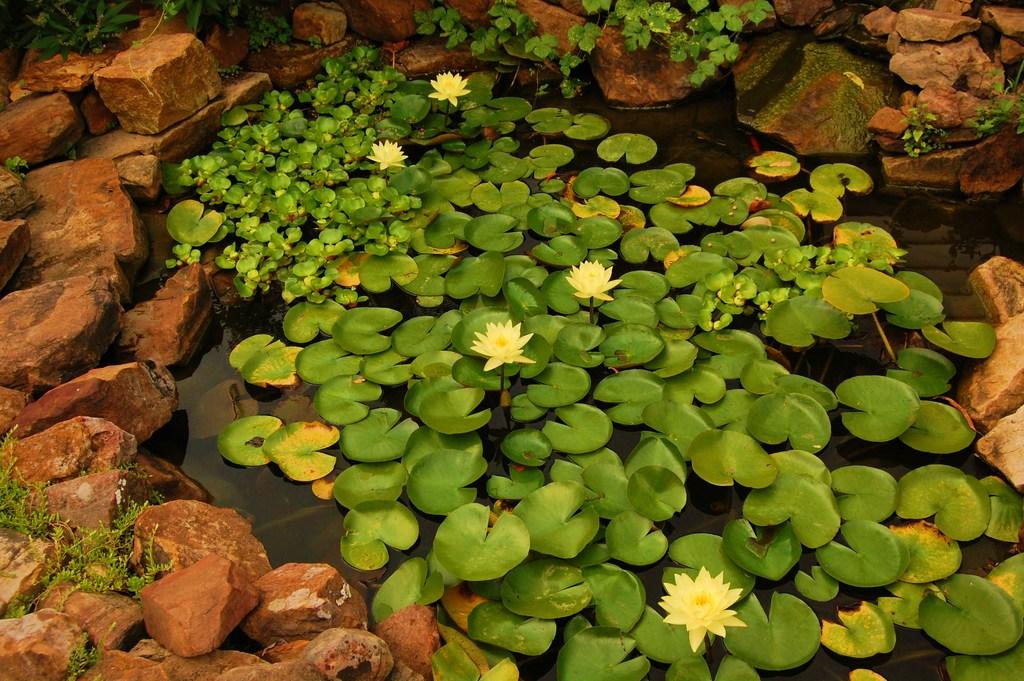What is located in the middle of the image? There is water in the middle of the image. What type of flowers can be seen in the water? Lotus flowers are present in the water. What color are the leaves visible in the water? Green color leaves are visible in the water. What surrounds the water in the image? There are stones around the water. What type of chair can be seen in the image? There is no chair present in the image. What territory is depicted in the image? The image does not depict any territory; it features water with lotus flowers and green leaves. 